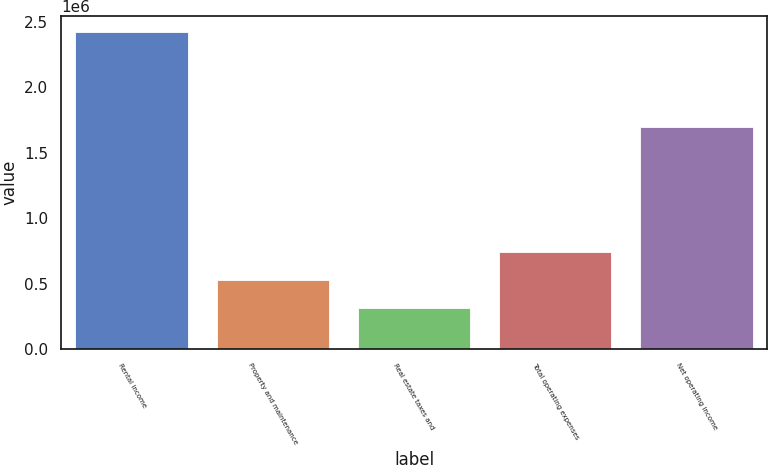<chart> <loc_0><loc_0><loc_500><loc_500><bar_chart><fcel>Rental income<fcel>Property and maintenance<fcel>Real estate taxes and<fcel>Total operating expenses<fcel>Net operating income<nl><fcel>2.42223e+06<fcel>527872<fcel>317387<fcel>738356<fcel>1.69802e+06<nl></chart> 